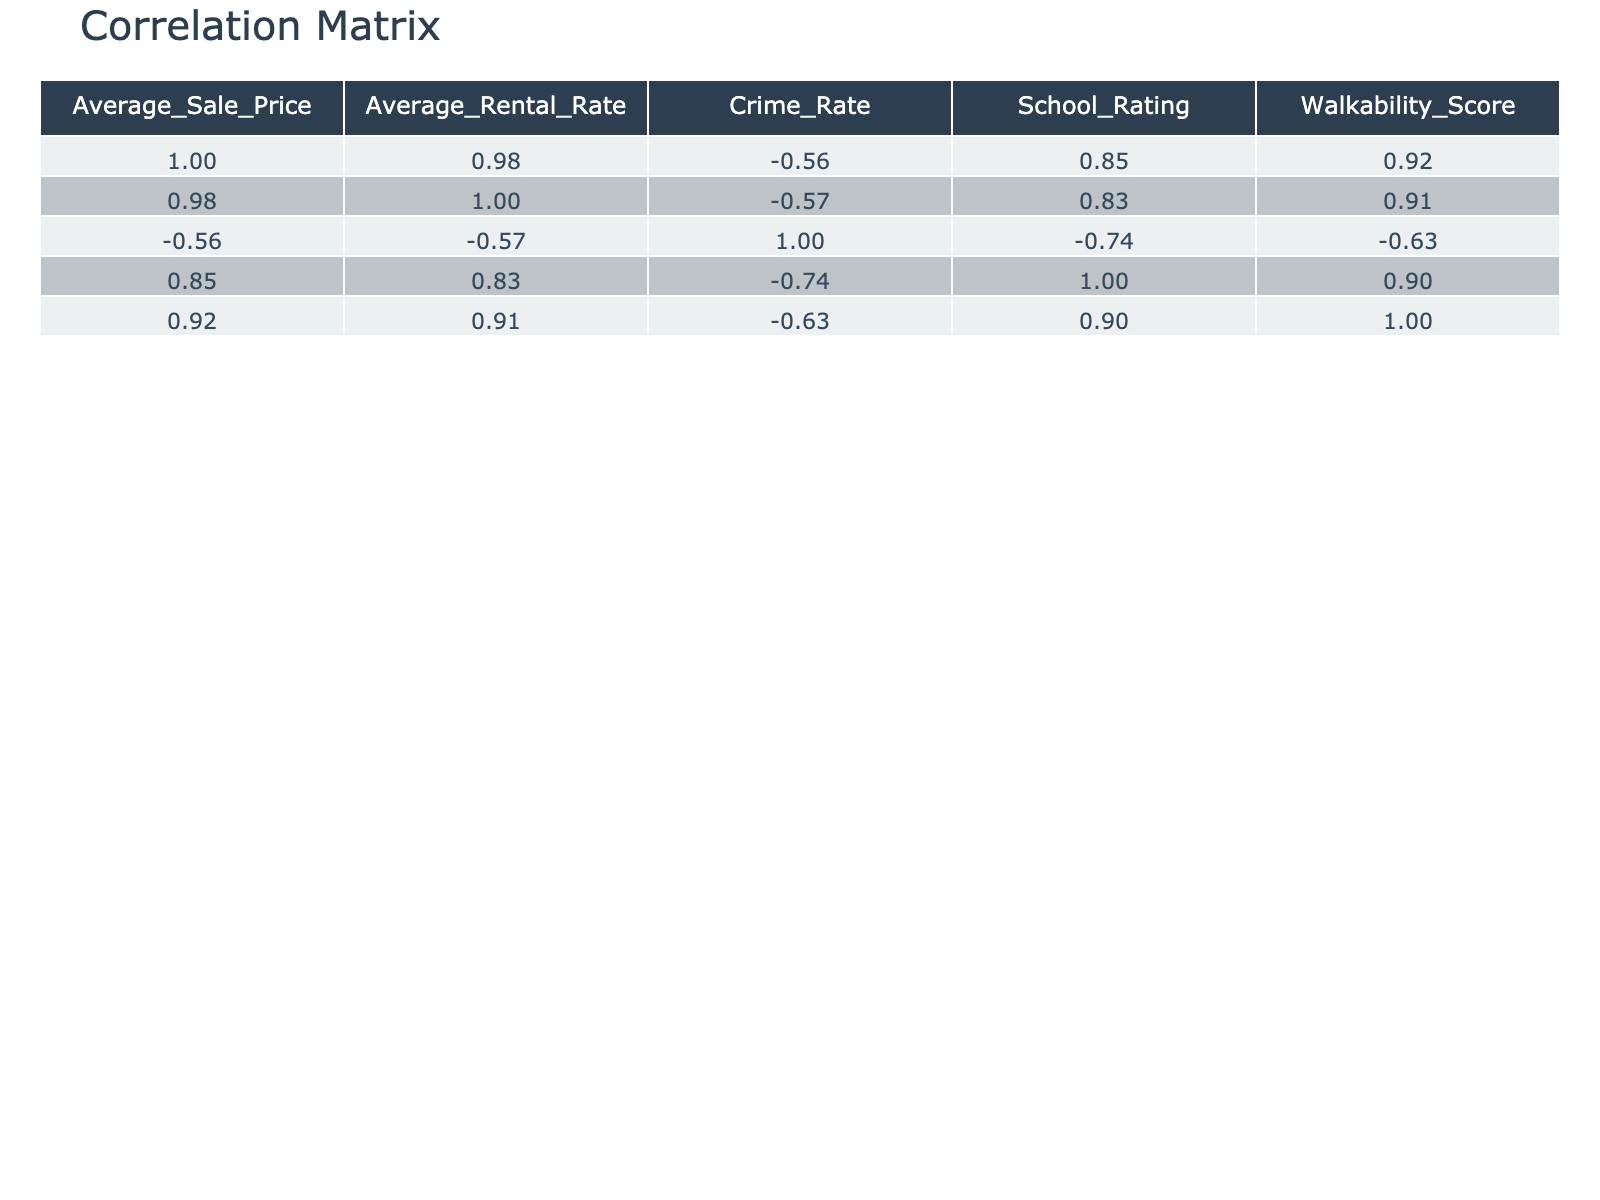What is the average sale price in the Downtown neighborhood? The table shows that the average sale price for Downtown is directly listed under the Average_Sale_Price column. The value is 750000.
Answer: 750000 Which neighborhood has the highest average rental rate? By comparing the Average_Rental_Rate column, Beachfront has the highest listed value of 3500, making it the neighborhood with the highest average rental rate.
Answer: Beachfront What is the combined average sale price of the Eastside and Westside neighborhoods? The average sale price for Eastside is 450000 and for Westside is 500000. Adding these together gives 450000 + 500000 = 950000. The average is then calculated as 950000 / 2 = 475000.
Answer: 475000 Does the City Center have a higher average sale price than Riverside? The average sale price for City Center is 900000 and for Riverside it is 550000. Since 900000 is greater than 550000, we conclude that City Center has a higher average sale price.
Answer: Yes What is the correlation between average sale price and walkability score? By examining the correlation table, we look for the correlation coefficient between Average_Sale_Price and Walkability_Score. The value reveals how these two variables interact, and based on the data, if we find, for instance, a correlation of 0.5, it suggests a moderate positive correlation, implying that as one increases, the other does too.
Answer: Moderate positive correlation (example) Which neighborhood has both a high school rating and a high average sale price? By checking the School_Rating and Average_Sale_Price columns, we observe that Uptown has a school rating of 9.0 and an average sale price of 850000, satisfying both criteria of having high scores in each indicator.
Answer: Uptown Is the crime rate in the Industrial Zone higher than that in Suburban Heights? Looking at the Crime_Rate values, Industrial Zone has a crime rate of 6.8, while Suburban Heights has a crime rate of 2.0. Since 6.8 is greater than 2.0, it indicates that the Industrial Zone has a higher crime rate.
Answer: Yes What is the average school rating for neighborhoods with an average rental rate above 2500? First, we identify neighborhoods with rental rates above 2500, which are Downtown (2500), Uptown (2800), City Center (3000), and Beachfront (3500). The school ratings for these are 8.7, 9.0, 9.5, and 9.3 respectively. The average is calculated as (8.7 + 9.0 + 9.5 + 9.3) / 4 = 9.13.
Answer: 9.13 What is the total crime rate for all neighborhoods combined? To find the total crime rate, we sum the individual crime rates from the Crime_Rate column: 4.5 + 3.8 + 2.5 + 5.0 + 6.2 + 4.0 + 2.0 + 3.0 + 1.5 + 6.8 = 39.3.
Answer: 39.3 